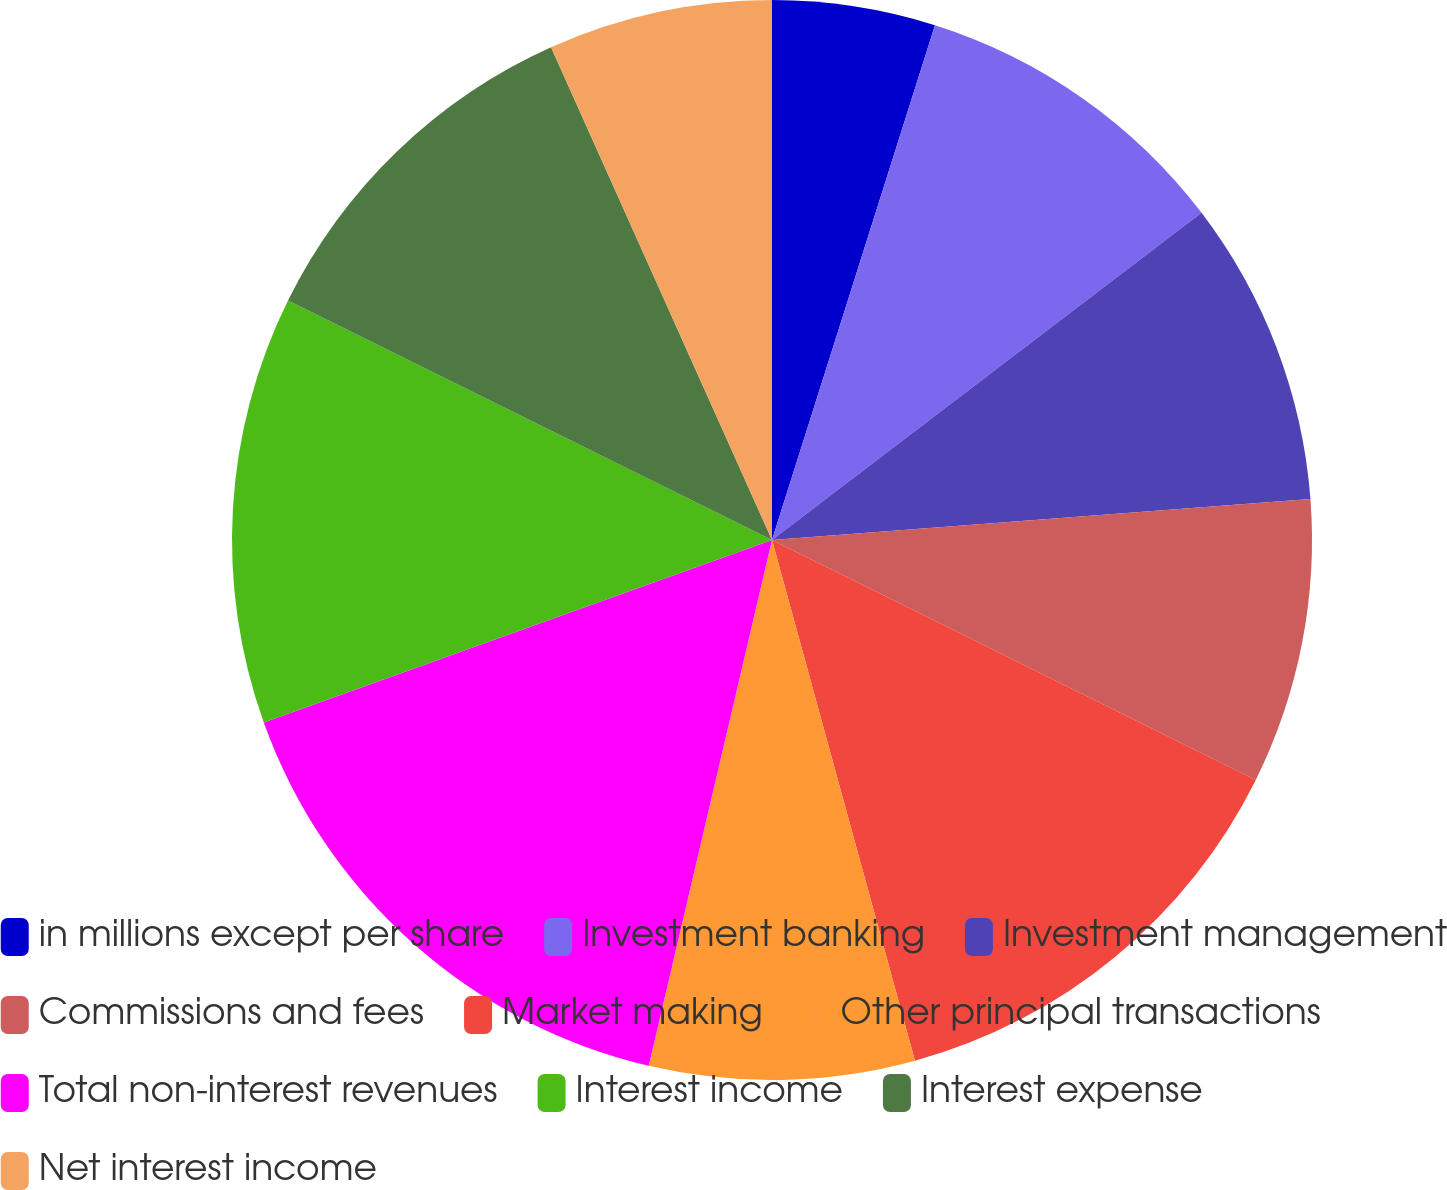Convert chart. <chart><loc_0><loc_0><loc_500><loc_500><pie_chart><fcel>in millions except per share<fcel>Investment banking<fcel>Investment management<fcel>Commissions and fees<fcel>Market making<fcel>Other principal transactions<fcel>Total non-interest revenues<fcel>Interest income<fcel>Interest expense<fcel>Net interest income<nl><fcel>4.88%<fcel>9.76%<fcel>9.15%<fcel>8.54%<fcel>13.41%<fcel>7.93%<fcel>15.85%<fcel>12.8%<fcel>10.98%<fcel>6.71%<nl></chart> 